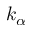Convert formula to latex. <formula><loc_0><loc_0><loc_500><loc_500>k _ { \alpha }</formula> 